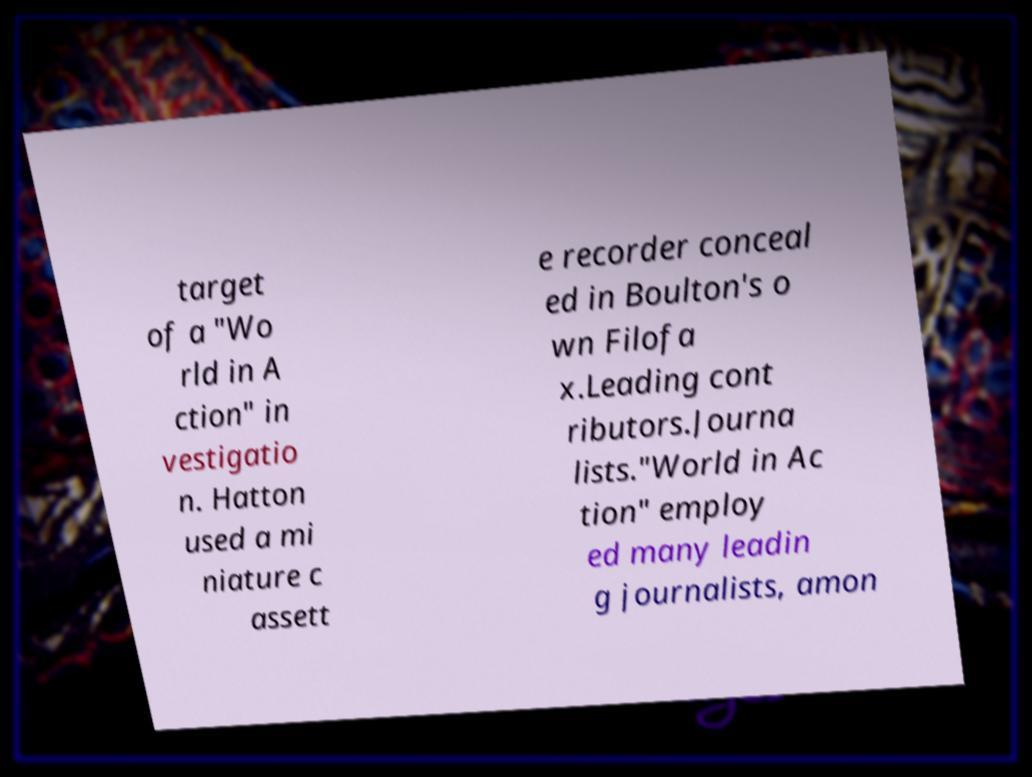Could you extract and type out the text from this image? target of a "Wo rld in A ction" in vestigatio n. Hatton used a mi niature c assett e recorder conceal ed in Boulton's o wn Filofa x.Leading cont ributors.Journa lists."World in Ac tion" employ ed many leadin g journalists, amon 